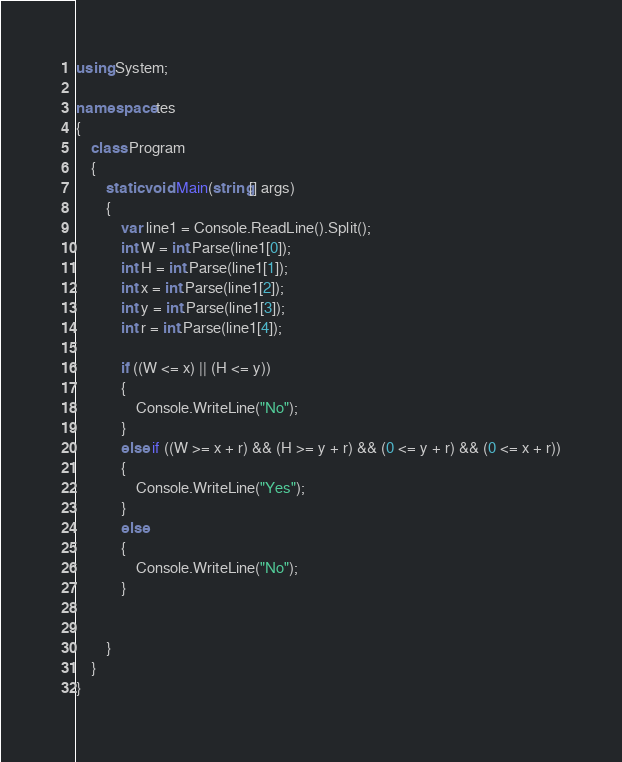<code> <loc_0><loc_0><loc_500><loc_500><_C#_>using System;

namespace tes
{
    class Program
    {
        static void Main(string[] args)
        {
            var line1 = Console.ReadLine().Split();
            int W = int.Parse(line1[0]);
            int H = int.Parse(line1[1]);
            int x = int.Parse(line1[2]);
            int y = int.Parse(line1[3]);
            int r = int.Parse(line1[4]);

            if ((W <= x) || (H <= y))
            {
                Console.WriteLine("No");
            }
            else if ((W >= x + r) && (H >= y + r) && (0 <= y + r) && (0 <= x + r))
            {
                Console.WriteLine("Yes");
            }
            else
            {
                Console.WriteLine("No");
            }

      
        }
    }
}</code> 